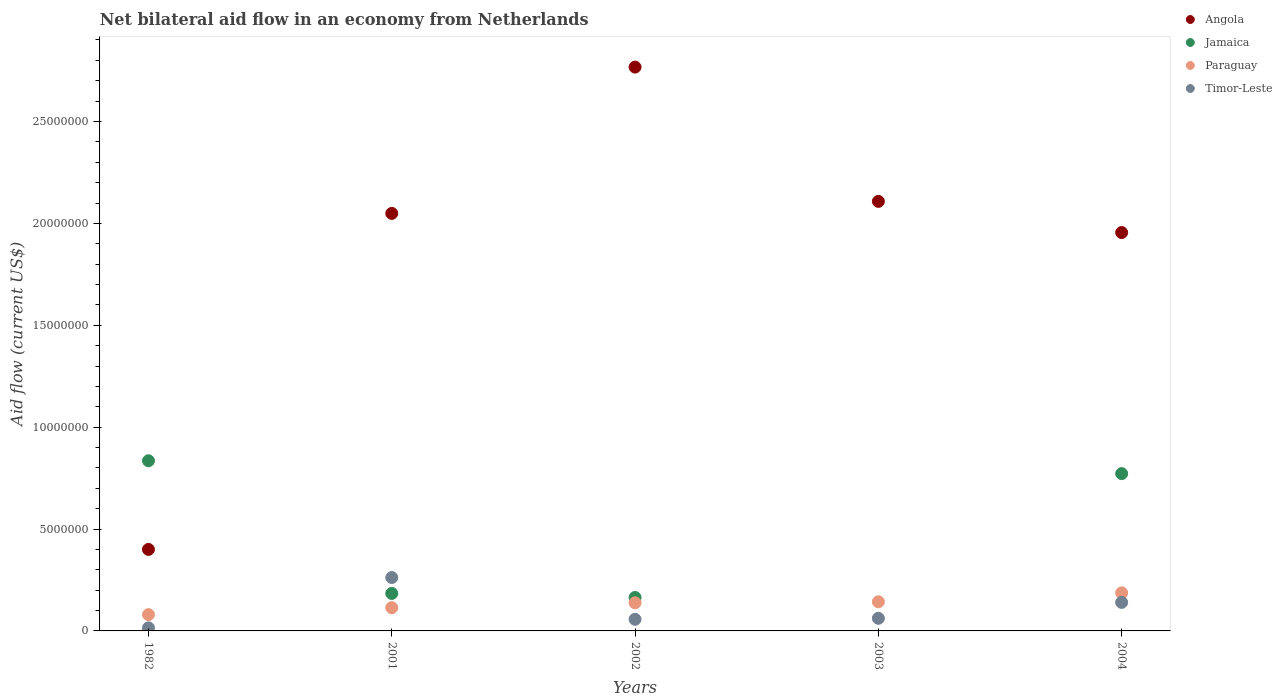How many different coloured dotlines are there?
Give a very brief answer. 4. What is the net bilateral aid flow in Jamaica in 2001?
Your response must be concise. 1.84e+06. Across all years, what is the maximum net bilateral aid flow in Timor-Leste?
Ensure brevity in your answer.  2.62e+06. Across all years, what is the minimum net bilateral aid flow in Angola?
Offer a very short reply. 4.00e+06. What is the total net bilateral aid flow in Timor-Leste in the graph?
Provide a succinct answer. 5.36e+06. What is the difference between the net bilateral aid flow in Angola in 2001 and that in 2004?
Offer a very short reply. 9.40e+05. What is the difference between the net bilateral aid flow in Timor-Leste in 2003 and the net bilateral aid flow in Jamaica in 2001?
Your answer should be very brief. -1.22e+06. What is the average net bilateral aid flow in Jamaica per year?
Provide a succinct answer. 3.91e+06. In the year 2001, what is the difference between the net bilateral aid flow in Angola and net bilateral aid flow in Jamaica?
Keep it short and to the point. 1.86e+07. In how many years, is the net bilateral aid flow in Paraguay greater than 3000000 US$?
Ensure brevity in your answer.  0. What is the ratio of the net bilateral aid flow in Paraguay in 1982 to that in 2002?
Provide a short and direct response. 0.58. What is the difference between the highest and the second highest net bilateral aid flow in Angola?
Offer a very short reply. 6.59e+06. What is the difference between the highest and the lowest net bilateral aid flow in Timor-Leste?
Ensure brevity in your answer.  2.47e+06. Is the sum of the net bilateral aid flow in Jamaica in 1982 and 2001 greater than the maximum net bilateral aid flow in Timor-Leste across all years?
Make the answer very short. Yes. Is the net bilateral aid flow in Jamaica strictly greater than the net bilateral aid flow in Paraguay over the years?
Your response must be concise. No. Is the net bilateral aid flow in Jamaica strictly less than the net bilateral aid flow in Angola over the years?
Make the answer very short. No. How many dotlines are there?
Make the answer very short. 4. Does the graph contain any zero values?
Make the answer very short. Yes. Does the graph contain grids?
Make the answer very short. No. How many legend labels are there?
Offer a terse response. 4. How are the legend labels stacked?
Your response must be concise. Vertical. What is the title of the graph?
Your answer should be compact. Net bilateral aid flow in an economy from Netherlands. Does "United States" appear as one of the legend labels in the graph?
Provide a short and direct response. No. What is the label or title of the X-axis?
Your response must be concise. Years. What is the label or title of the Y-axis?
Provide a succinct answer. Aid flow (current US$). What is the Aid flow (current US$) in Jamaica in 1982?
Offer a very short reply. 8.35e+06. What is the Aid flow (current US$) of Timor-Leste in 1982?
Offer a terse response. 1.50e+05. What is the Aid flow (current US$) in Angola in 2001?
Provide a short and direct response. 2.05e+07. What is the Aid flow (current US$) of Jamaica in 2001?
Ensure brevity in your answer.  1.84e+06. What is the Aid flow (current US$) of Paraguay in 2001?
Provide a succinct answer. 1.14e+06. What is the Aid flow (current US$) of Timor-Leste in 2001?
Provide a short and direct response. 2.62e+06. What is the Aid flow (current US$) of Angola in 2002?
Your response must be concise. 2.77e+07. What is the Aid flow (current US$) of Jamaica in 2002?
Give a very brief answer. 1.64e+06. What is the Aid flow (current US$) of Paraguay in 2002?
Ensure brevity in your answer.  1.38e+06. What is the Aid flow (current US$) in Timor-Leste in 2002?
Make the answer very short. 5.70e+05. What is the Aid flow (current US$) of Angola in 2003?
Provide a short and direct response. 2.11e+07. What is the Aid flow (current US$) of Paraguay in 2003?
Give a very brief answer. 1.43e+06. What is the Aid flow (current US$) of Timor-Leste in 2003?
Give a very brief answer. 6.20e+05. What is the Aid flow (current US$) of Angola in 2004?
Give a very brief answer. 1.96e+07. What is the Aid flow (current US$) in Jamaica in 2004?
Ensure brevity in your answer.  7.72e+06. What is the Aid flow (current US$) of Paraguay in 2004?
Make the answer very short. 1.87e+06. What is the Aid flow (current US$) of Timor-Leste in 2004?
Offer a very short reply. 1.40e+06. Across all years, what is the maximum Aid flow (current US$) in Angola?
Offer a very short reply. 2.77e+07. Across all years, what is the maximum Aid flow (current US$) of Jamaica?
Ensure brevity in your answer.  8.35e+06. Across all years, what is the maximum Aid flow (current US$) in Paraguay?
Offer a very short reply. 1.87e+06. Across all years, what is the maximum Aid flow (current US$) of Timor-Leste?
Provide a succinct answer. 2.62e+06. What is the total Aid flow (current US$) in Angola in the graph?
Keep it short and to the point. 9.28e+07. What is the total Aid flow (current US$) of Jamaica in the graph?
Your answer should be compact. 1.96e+07. What is the total Aid flow (current US$) in Paraguay in the graph?
Make the answer very short. 6.62e+06. What is the total Aid flow (current US$) in Timor-Leste in the graph?
Offer a terse response. 5.36e+06. What is the difference between the Aid flow (current US$) in Angola in 1982 and that in 2001?
Offer a terse response. -1.65e+07. What is the difference between the Aid flow (current US$) in Jamaica in 1982 and that in 2001?
Offer a very short reply. 6.51e+06. What is the difference between the Aid flow (current US$) of Paraguay in 1982 and that in 2001?
Ensure brevity in your answer.  -3.40e+05. What is the difference between the Aid flow (current US$) in Timor-Leste in 1982 and that in 2001?
Give a very brief answer. -2.47e+06. What is the difference between the Aid flow (current US$) in Angola in 1982 and that in 2002?
Offer a very short reply. -2.37e+07. What is the difference between the Aid flow (current US$) in Jamaica in 1982 and that in 2002?
Ensure brevity in your answer.  6.71e+06. What is the difference between the Aid flow (current US$) of Paraguay in 1982 and that in 2002?
Offer a very short reply. -5.80e+05. What is the difference between the Aid flow (current US$) in Timor-Leste in 1982 and that in 2002?
Provide a succinct answer. -4.20e+05. What is the difference between the Aid flow (current US$) in Angola in 1982 and that in 2003?
Keep it short and to the point. -1.71e+07. What is the difference between the Aid flow (current US$) of Paraguay in 1982 and that in 2003?
Make the answer very short. -6.30e+05. What is the difference between the Aid flow (current US$) in Timor-Leste in 1982 and that in 2003?
Keep it short and to the point. -4.70e+05. What is the difference between the Aid flow (current US$) in Angola in 1982 and that in 2004?
Your answer should be compact. -1.56e+07. What is the difference between the Aid flow (current US$) of Jamaica in 1982 and that in 2004?
Make the answer very short. 6.30e+05. What is the difference between the Aid flow (current US$) in Paraguay in 1982 and that in 2004?
Your response must be concise. -1.07e+06. What is the difference between the Aid flow (current US$) of Timor-Leste in 1982 and that in 2004?
Provide a short and direct response. -1.25e+06. What is the difference between the Aid flow (current US$) in Angola in 2001 and that in 2002?
Your answer should be very brief. -7.18e+06. What is the difference between the Aid flow (current US$) of Jamaica in 2001 and that in 2002?
Make the answer very short. 2.00e+05. What is the difference between the Aid flow (current US$) of Timor-Leste in 2001 and that in 2002?
Provide a succinct answer. 2.05e+06. What is the difference between the Aid flow (current US$) of Angola in 2001 and that in 2003?
Keep it short and to the point. -5.90e+05. What is the difference between the Aid flow (current US$) of Paraguay in 2001 and that in 2003?
Give a very brief answer. -2.90e+05. What is the difference between the Aid flow (current US$) of Angola in 2001 and that in 2004?
Your response must be concise. 9.40e+05. What is the difference between the Aid flow (current US$) of Jamaica in 2001 and that in 2004?
Ensure brevity in your answer.  -5.88e+06. What is the difference between the Aid flow (current US$) of Paraguay in 2001 and that in 2004?
Offer a terse response. -7.30e+05. What is the difference between the Aid flow (current US$) of Timor-Leste in 2001 and that in 2004?
Keep it short and to the point. 1.22e+06. What is the difference between the Aid flow (current US$) in Angola in 2002 and that in 2003?
Keep it short and to the point. 6.59e+06. What is the difference between the Aid flow (current US$) in Paraguay in 2002 and that in 2003?
Provide a short and direct response. -5.00e+04. What is the difference between the Aid flow (current US$) in Timor-Leste in 2002 and that in 2003?
Keep it short and to the point. -5.00e+04. What is the difference between the Aid flow (current US$) of Angola in 2002 and that in 2004?
Make the answer very short. 8.12e+06. What is the difference between the Aid flow (current US$) of Jamaica in 2002 and that in 2004?
Make the answer very short. -6.08e+06. What is the difference between the Aid flow (current US$) of Paraguay in 2002 and that in 2004?
Ensure brevity in your answer.  -4.90e+05. What is the difference between the Aid flow (current US$) of Timor-Leste in 2002 and that in 2004?
Offer a very short reply. -8.30e+05. What is the difference between the Aid flow (current US$) in Angola in 2003 and that in 2004?
Provide a succinct answer. 1.53e+06. What is the difference between the Aid flow (current US$) of Paraguay in 2003 and that in 2004?
Keep it short and to the point. -4.40e+05. What is the difference between the Aid flow (current US$) of Timor-Leste in 2003 and that in 2004?
Your answer should be very brief. -7.80e+05. What is the difference between the Aid flow (current US$) of Angola in 1982 and the Aid flow (current US$) of Jamaica in 2001?
Offer a terse response. 2.16e+06. What is the difference between the Aid flow (current US$) of Angola in 1982 and the Aid flow (current US$) of Paraguay in 2001?
Offer a terse response. 2.86e+06. What is the difference between the Aid flow (current US$) of Angola in 1982 and the Aid flow (current US$) of Timor-Leste in 2001?
Offer a very short reply. 1.38e+06. What is the difference between the Aid flow (current US$) of Jamaica in 1982 and the Aid flow (current US$) of Paraguay in 2001?
Your response must be concise. 7.21e+06. What is the difference between the Aid flow (current US$) in Jamaica in 1982 and the Aid flow (current US$) in Timor-Leste in 2001?
Offer a very short reply. 5.73e+06. What is the difference between the Aid flow (current US$) of Paraguay in 1982 and the Aid flow (current US$) of Timor-Leste in 2001?
Make the answer very short. -1.82e+06. What is the difference between the Aid flow (current US$) of Angola in 1982 and the Aid flow (current US$) of Jamaica in 2002?
Provide a short and direct response. 2.36e+06. What is the difference between the Aid flow (current US$) in Angola in 1982 and the Aid flow (current US$) in Paraguay in 2002?
Your response must be concise. 2.62e+06. What is the difference between the Aid flow (current US$) of Angola in 1982 and the Aid flow (current US$) of Timor-Leste in 2002?
Give a very brief answer. 3.43e+06. What is the difference between the Aid flow (current US$) in Jamaica in 1982 and the Aid flow (current US$) in Paraguay in 2002?
Provide a succinct answer. 6.97e+06. What is the difference between the Aid flow (current US$) of Jamaica in 1982 and the Aid flow (current US$) of Timor-Leste in 2002?
Ensure brevity in your answer.  7.78e+06. What is the difference between the Aid flow (current US$) of Angola in 1982 and the Aid flow (current US$) of Paraguay in 2003?
Give a very brief answer. 2.57e+06. What is the difference between the Aid flow (current US$) in Angola in 1982 and the Aid flow (current US$) in Timor-Leste in 2003?
Provide a short and direct response. 3.38e+06. What is the difference between the Aid flow (current US$) in Jamaica in 1982 and the Aid flow (current US$) in Paraguay in 2003?
Make the answer very short. 6.92e+06. What is the difference between the Aid flow (current US$) in Jamaica in 1982 and the Aid flow (current US$) in Timor-Leste in 2003?
Provide a short and direct response. 7.73e+06. What is the difference between the Aid flow (current US$) in Angola in 1982 and the Aid flow (current US$) in Jamaica in 2004?
Your answer should be compact. -3.72e+06. What is the difference between the Aid flow (current US$) in Angola in 1982 and the Aid flow (current US$) in Paraguay in 2004?
Offer a terse response. 2.13e+06. What is the difference between the Aid flow (current US$) of Angola in 1982 and the Aid flow (current US$) of Timor-Leste in 2004?
Your response must be concise. 2.60e+06. What is the difference between the Aid flow (current US$) of Jamaica in 1982 and the Aid flow (current US$) of Paraguay in 2004?
Ensure brevity in your answer.  6.48e+06. What is the difference between the Aid flow (current US$) of Jamaica in 1982 and the Aid flow (current US$) of Timor-Leste in 2004?
Keep it short and to the point. 6.95e+06. What is the difference between the Aid flow (current US$) of Paraguay in 1982 and the Aid flow (current US$) of Timor-Leste in 2004?
Ensure brevity in your answer.  -6.00e+05. What is the difference between the Aid flow (current US$) of Angola in 2001 and the Aid flow (current US$) of Jamaica in 2002?
Your answer should be compact. 1.88e+07. What is the difference between the Aid flow (current US$) of Angola in 2001 and the Aid flow (current US$) of Paraguay in 2002?
Offer a very short reply. 1.91e+07. What is the difference between the Aid flow (current US$) in Angola in 2001 and the Aid flow (current US$) in Timor-Leste in 2002?
Your response must be concise. 1.99e+07. What is the difference between the Aid flow (current US$) in Jamaica in 2001 and the Aid flow (current US$) in Timor-Leste in 2002?
Make the answer very short. 1.27e+06. What is the difference between the Aid flow (current US$) of Paraguay in 2001 and the Aid flow (current US$) of Timor-Leste in 2002?
Offer a terse response. 5.70e+05. What is the difference between the Aid flow (current US$) of Angola in 2001 and the Aid flow (current US$) of Paraguay in 2003?
Ensure brevity in your answer.  1.91e+07. What is the difference between the Aid flow (current US$) of Angola in 2001 and the Aid flow (current US$) of Timor-Leste in 2003?
Provide a succinct answer. 1.99e+07. What is the difference between the Aid flow (current US$) of Jamaica in 2001 and the Aid flow (current US$) of Timor-Leste in 2003?
Your answer should be compact. 1.22e+06. What is the difference between the Aid flow (current US$) in Paraguay in 2001 and the Aid flow (current US$) in Timor-Leste in 2003?
Make the answer very short. 5.20e+05. What is the difference between the Aid flow (current US$) of Angola in 2001 and the Aid flow (current US$) of Jamaica in 2004?
Ensure brevity in your answer.  1.28e+07. What is the difference between the Aid flow (current US$) of Angola in 2001 and the Aid flow (current US$) of Paraguay in 2004?
Keep it short and to the point. 1.86e+07. What is the difference between the Aid flow (current US$) in Angola in 2001 and the Aid flow (current US$) in Timor-Leste in 2004?
Give a very brief answer. 1.91e+07. What is the difference between the Aid flow (current US$) in Jamaica in 2001 and the Aid flow (current US$) in Paraguay in 2004?
Your response must be concise. -3.00e+04. What is the difference between the Aid flow (current US$) in Angola in 2002 and the Aid flow (current US$) in Paraguay in 2003?
Offer a very short reply. 2.62e+07. What is the difference between the Aid flow (current US$) in Angola in 2002 and the Aid flow (current US$) in Timor-Leste in 2003?
Your answer should be very brief. 2.70e+07. What is the difference between the Aid flow (current US$) of Jamaica in 2002 and the Aid flow (current US$) of Paraguay in 2003?
Ensure brevity in your answer.  2.10e+05. What is the difference between the Aid flow (current US$) in Jamaica in 2002 and the Aid flow (current US$) in Timor-Leste in 2003?
Your answer should be compact. 1.02e+06. What is the difference between the Aid flow (current US$) of Paraguay in 2002 and the Aid flow (current US$) of Timor-Leste in 2003?
Offer a very short reply. 7.60e+05. What is the difference between the Aid flow (current US$) of Angola in 2002 and the Aid flow (current US$) of Jamaica in 2004?
Your answer should be compact. 2.00e+07. What is the difference between the Aid flow (current US$) in Angola in 2002 and the Aid flow (current US$) in Paraguay in 2004?
Offer a terse response. 2.58e+07. What is the difference between the Aid flow (current US$) in Angola in 2002 and the Aid flow (current US$) in Timor-Leste in 2004?
Your answer should be compact. 2.63e+07. What is the difference between the Aid flow (current US$) in Angola in 2003 and the Aid flow (current US$) in Jamaica in 2004?
Offer a very short reply. 1.34e+07. What is the difference between the Aid flow (current US$) of Angola in 2003 and the Aid flow (current US$) of Paraguay in 2004?
Keep it short and to the point. 1.92e+07. What is the difference between the Aid flow (current US$) of Angola in 2003 and the Aid flow (current US$) of Timor-Leste in 2004?
Give a very brief answer. 1.97e+07. What is the average Aid flow (current US$) in Angola per year?
Your answer should be compact. 1.86e+07. What is the average Aid flow (current US$) in Jamaica per year?
Your answer should be compact. 3.91e+06. What is the average Aid flow (current US$) of Paraguay per year?
Offer a very short reply. 1.32e+06. What is the average Aid flow (current US$) of Timor-Leste per year?
Offer a terse response. 1.07e+06. In the year 1982, what is the difference between the Aid flow (current US$) in Angola and Aid flow (current US$) in Jamaica?
Your answer should be compact. -4.35e+06. In the year 1982, what is the difference between the Aid flow (current US$) of Angola and Aid flow (current US$) of Paraguay?
Give a very brief answer. 3.20e+06. In the year 1982, what is the difference between the Aid flow (current US$) in Angola and Aid flow (current US$) in Timor-Leste?
Offer a terse response. 3.85e+06. In the year 1982, what is the difference between the Aid flow (current US$) in Jamaica and Aid flow (current US$) in Paraguay?
Make the answer very short. 7.55e+06. In the year 1982, what is the difference between the Aid flow (current US$) of Jamaica and Aid flow (current US$) of Timor-Leste?
Ensure brevity in your answer.  8.20e+06. In the year 1982, what is the difference between the Aid flow (current US$) of Paraguay and Aid flow (current US$) of Timor-Leste?
Offer a terse response. 6.50e+05. In the year 2001, what is the difference between the Aid flow (current US$) of Angola and Aid flow (current US$) of Jamaica?
Give a very brief answer. 1.86e+07. In the year 2001, what is the difference between the Aid flow (current US$) in Angola and Aid flow (current US$) in Paraguay?
Keep it short and to the point. 1.94e+07. In the year 2001, what is the difference between the Aid flow (current US$) in Angola and Aid flow (current US$) in Timor-Leste?
Your response must be concise. 1.79e+07. In the year 2001, what is the difference between the Aid flow (current US$) in Jamaica and Aid flow (current US$) in Paraguay?
Provide a short and direct response. 7.00e+05. In the year 2001, what is the difference between the Aid flow (current US$) of Jamaica and Aid flow (current US$) of Timor-Leste?
Provide a succinct answer. -7.80e+05. In the year 2001, what is the difference between the Aid flow (current US$) in Paraguay and Aid flow (current US$) in Timor-Leste?
Provide a short and direct response. -1.48e+06. In the year 2002, what is the difference between the Aid flow (current US$) in Angola and Aid flow (current US$) in Jamaica?
Make the answer very short. 2.60e+07. In the year 2002, what is the difference between the Aid flow (current US$) of Angola and Aid flow (current US$) of Paraguay?
Offer a very short reply. 2.63e+07. In the year 2002, what is the difference between the Aid flow (current US$) of Angola and Aid flow (current US$) of Timor-Leste?
Offer a terse response. 2.71e+07. In the year 2002, what is the difference between the Aid flow (current US$) of Jamaica and Aid flow (current US$) of Timor-Leste?
Provide a succinct answer. 1.07e+06. In the year 2002, what is the difference between the Aid flow (current US$) of Paraguay and Aid flow (current US$) of Timor-Leste?
Provide a short and direct response. 8.10e+05. In the year 2003, what is the difference between the Aid flow (current US$) in Angola and Aid flow (current US$) in Paraguay?
Ensure brevity in your answer.  1.96e+07. In the year 2003, what is the difference between the Aid flow (current US$) in Angola and Aid flow (current US$) in Timor-Leste?
Provide a short and direct response. 2.05e+07. In the year 2003, what is the difference between the Aid flow (current US$) of Paraguay and Aid flow (current US$) of Timor-Leste?
Provide a succinct answer. 8.10e+05. In the year 2004, what is the difference between the Aid flow (current US$) of Angola and Aid flow (current US$) of Jamaica?
Make the answer very short. 1.18e+07. In the year 2004, what is the difference between the Aid flow (current US$) of Angola and Aid flow (current US$) of Paraguay?
Make the answer very short. 1.77e+07. In the year 2004, what is the difference between the Aid flow (current US$) of Angola and Aid flow (current US$) of Timor-Leste?
Ensure brevity in your answer.  1.82e+07. In the year 2004, what is the difference between the Aid flow (current US$) in Jamaica and Aid flow (current US$) in Paraguay?
Give a very brief answer. 5.85e+06. In the year 2004, what is the difference between the Aid flow (current US$) of Jamaica and Aid flow (current US$) of Timor-Leste?
Your answer should be very brief. 6.32e+06. What is the ratio of the Aid flow (current US$) in Angola in 1982 to that in 2001?
Provide a short and direct response. 0.2. What is the ratio of the Aid flow (current US$) of Jamaica in 1982 to that in 2001?
Your answer should be very brief. 4.54. What is the ratio of the Aid flow (current US$) of Paraguay in 1982 to that in 2001?
Offer a very short reply. 0.7. What is the ratio of the Aid flow (current US$) of Timor-Leste in 1982 to that in 2001?
Offer a very short reply. 0.06. What is the ratio of the Aid flow (current US$) in Angola in 1982 to that in 2002?
Offer a terse response. 0.14. What is the ratio of the Aid flow (current US$) in Jamaica in 1982 to that in 2002?
Your response must be concise. 5.09. What is the ratio of the Aid flow (current US$) of Paraguay in 1982 to that in 2002?
Offer a terse response. 0.58. What is the ratio of the Aid flow (current US$) in Timor-Leste in 1982 to that in 2002?
Ensure brevity in your answer.  0.26. What is the ratio of the Aid flow (current US$) of Angola in 1982 to that in 2003?
Offer a terse response. 0.19. What is the ratio of the Aid flow (current US$) of Paraguay in 1982 to that in 2003?
Provide a succinct answer. 0.56. What is the ratio of the Aid flow (current US$) of Timor-Leste in 1982 to that in 2003?
Offer a very short reply. 0.24. What is the ratio of the Aid flow (current US$) in Angola in 1982 to that in 2004?
Your response must be concise. 0.2. What is the ratio of the Aid flow (current US$) in Jamaica in 1982 to that in 2004?
Your answer should be very brief. 1.08. What is the ratio of the Aid flow (current US$) in Paraguay in 1982 to that in 2004?
Provide a short and direct response. 0.43. What is the ratio of the Aid flow (current US$) in Timor-Leste in 1982 to that in 2004?
Offer a terse response. 0.11. What is the ratio of the Aid flow (current US$) in Angola in 2001 to that in 2002?
Your response must be concise. 0.74. What is the ratio of the Aid flow (current US$) in Jamaica in 2001 to that in 2002?
Your answer should be compact. 1.12. What is the ratio of the Aid flow (current US$) of Paraguay in 2001 to that in 2002?
Ensure brevity in your answer.  0.83. What is the ratio of the Aid flow (current US$) of Timor-Leste in 2001 to that in 2002?
Your response must be concise. 4.6. What is the ratio of the Aid flow (current US$) in Angola in 2001 to that in 2003?
Your answer should be very brief. 0.97. What is the ratio of the Aid flow (current US$) in Paraguay in 2001 to that in 2003?
Offer a very short reply. 0.8. What is the ratio of the Aid flow (current US$) in Timor-Leste in 2001 to that in 2003?
Make the answer very short. 4.23. What is the ratio of the Aid flow (current US$) in Angola in 2001 to that in 2004?
Give a very brief answer. 1.05. What is the ratio of the Aid flow (current US$) in Jamaica in 2001 to that in 2004?
Give a very brief answer. 0.24. What is the ratio of the Aid flow (current US$) in Paraguay in 2001 to that in 2004?
Your answer should be very brief. 0.61. What is the ratio of the Aid flow (current US$) of Timor-Leste in 2001 to that in 2004?
Offer a very short reply. 1.87. What is the ratio of the Aid flow (current US$) of Angola in 2002 to that in 2003?
Your response must be concise. 1.31. What is the ratio of the Aid flow (current US$) of Paraguay in 2002 to that in 2003?
Give a very brief answer. 0.96. What is the ratio of the Aid flow (current US$) in Timor-Leste in 2002 to that in 2003?
Provide a succinct answer. 0.92. What is the ratio of the Aid flow (current US$) in Angola in 2002 to that in 2004?
Your answer should be compact. 1.42. What is the ratio of the Aid flow (current US$) in Jamaica in 2002 to that in 2004?
Your answer should be very brief. 0.21. What is the ratio of the Aid flow (current US$) of Paraguay in 2002 to that in 2004?
Make the answer very short. 0.74. What is the ratio of the Aid flow (current US$) of Timor-Leste in 2002 to that in 2004?
Offer a very short reply. 0.41. What is the ratio of the Aid flow (current US$) of Angola in 2003 to that in 2004?
Ensure brevity in your answer.  1.08. What is the ratio of the Aid flow (current US$) of Paraguay in 2003 to that in 2004?
Provide a short and direct response. 0.76. What is the ratio of the Aid flow (current US$) of Timor-Leste in 2003 to that in 2004?
Provide a succinct answer. 0.44. What is the difference between the highest and the second highest Aid flow (current US$) of Angola?
Your response must be concise. 6.59e+06. What is the difference between the highest and the second highest Aid flow (current US$) in Jamaica?
Provide a short and direct response. 6.30e+05. What is the difference between the highest and the second highest Aid flow (current US$) in Paraguay?
Offer a very short reply. 4.40e+05. What is the difference between the highest and the second highest Aid flow (current US$) in Timor-Leste?
Make the answer very short. 1.22e+06. What is the difference between the highest and the lowest Aid flow (current US$) of Angola?
Provide a succinct answer. 2.37e+07. What is the difference between the highest and the lowest Aid flow (current US$) of Jamaica?
Your answer should be compact. 8.35e+06. What is the difference between the highest and the lowest Aid flow (current US$) in Paraguay?
Offer a terse response. 1.07e+06. What is the difference between the highest and the lowest Aid flow (current US$) in Timor-Leste?
Make the answer very short. 2.47e+06. 